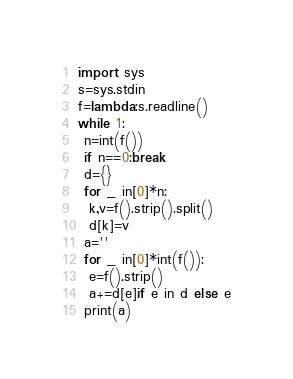<code> <loc_0><loc_0><loc_500><loc_500><_Python_>import sys
s=sys.stdin
f=lambda:s.readline()
while 1:
 n=int(f())
 if n==0:break
 d={}
 for _ in[0]*n:
  k,v=f().strip().split()
  d[k]=v
 a=''
 for _ in[0]*int(f()):
  e=f().strip()
  a+=d[e]if e in d else e
 print(a)
</code> 